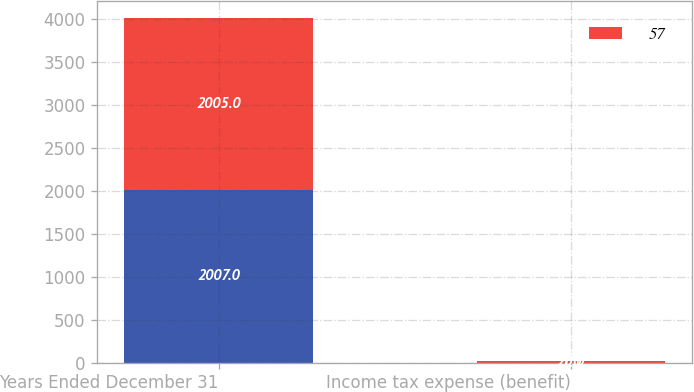Convert chart. <chart><loc_0><loc_0><loc_500><loc_500><stacked_bar_chart><ecel><fcel>Years Ended December 31<fcel>Income tax expense (benefit)<nl><fcel>nan<fcel>2007<fcel>1<nl><fcel>57<fcel>2005<fcel>20<nl></chart> 